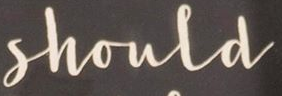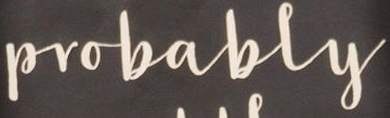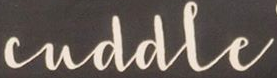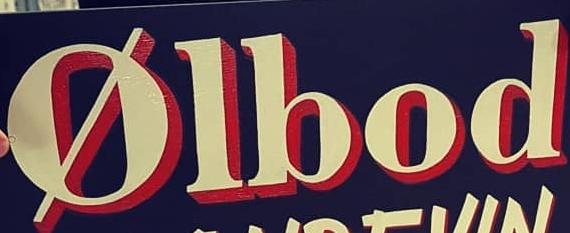Read the text content from these images in order, separated by a semicolon. Shoula; Probably; cuddle; Ølbod 